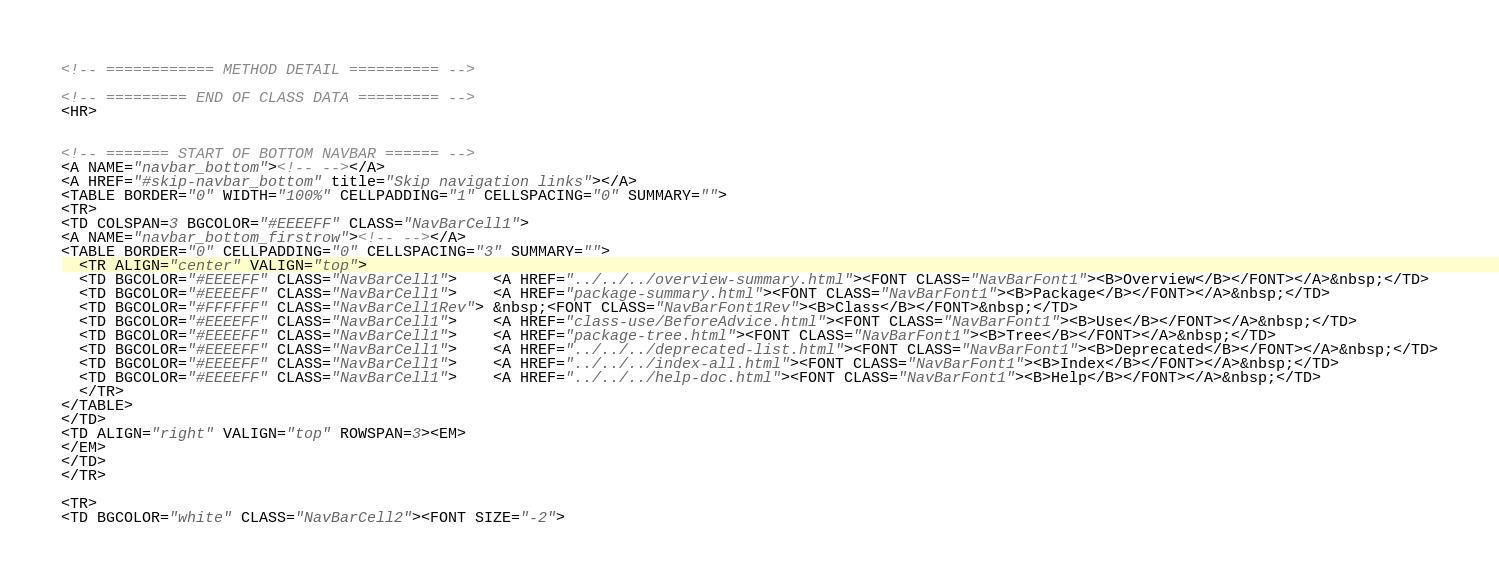Convert code to text. <code><loc_0><loc_0><loc_500><loc_500><_HTML_><!-- ============ METHOD DETAIL ========== -->

<!-- ========= END OF CLASS DATA ========= -->
<HR>


<!-- ======= START OF BOTTOM NAVBAR ====== -->
<A NAME="navbar_bottom"><!-- --></A>
<A HREF="#skip-navbar_bottom" title="Skip navigation links"></A>
<TABLE BORDER="0" WIDTH="100%" CELLPADDING="1" CELLSPACING="0" SUMMARY="">
<TR>
<TD COLSPAN=3 BGCOLOR="#EEEEFF" CLASS="NavBarCell1">
<A NAME="navbar_bottom_firstrow"><!-- --></A>
<TABLE BORDER="0" CELLPADDING="0" CELLSPACING="3" SUMMARY="">
  <TR ALIGN="center" VALIGN="top">
  <TD BGCOLOR="#EEEEFF" CLASS="NavBarCell1">    <A HREF="../../../overview-summary.html"><FONT CLASS="NavBarFont1"><B>Overview</B></FONT></A>&nbsp;</TD>
  <TD BGCOLOR="#EEEEFF" CLASS="NavBarCell1">    <A HREF="package-summary.html"><FONT CLASS="NavBarFont1"><B>Package</B></FONT></A>&nbsp;</TD>
  <TD BGCOLOR="#FFFFFF" CLASS="NavBarCell1Rev"> &nbsp;<FONT CLASS="NavBarFont1Rev"><B>Class</B></FONT>&nbsp;</TD>
  <TD BGCOLOR="#EEEEFF" CLASS="NavBarCell1">    <A HREF="class-use/BeforeAdvice.html"><FONT CLASS="NavBarFont1"><B>Use</B></FONT></A>&nbsp;</TD>
  <TD BGCOLOR="#EEEEFF" CLASS="NavBarCell1">    <A HREF="package-tree.html"><FONT CLASS="NavBarFont1"><B>Tree</B></FONT></A>&nbsp;</TD>
  <TD BGCOLOR="#EEEEFF" CLASS="NavBarCell1">    <A HREF="../../../deprecated-list.html"><FONT CLASS="NavBarFont1"><B>Deprecated</B></FONT></A>&nbsp;</TD>
  <TD BGCOLOR="#EEEEFF" CLASS="NavBarCell1">    <A HREF="../../../index-all.html"><FONT CLASS="NavBarFont1"><B>Index</B></FONT></A>&nbsp;</TD>
  <TD BGCOLOR="#EEEEFF" CLASS="NavBarCell1">    <A HREF="../../../help-doc.html"><FONT CLASS="NavBarFont1"><B>Help</B></FONT></A>&nbsp;</TD>
  </TR>
</TABLE>
</TD>
<TD ALIGN="right" VALIGN="top" ROWSPAN=3><EM>
</EM>
</TD>
</TR>

<TR>
<TD BGCOLOR="white" CLASS="NavBarCell2"><FONT SIZE="-2"></code> 